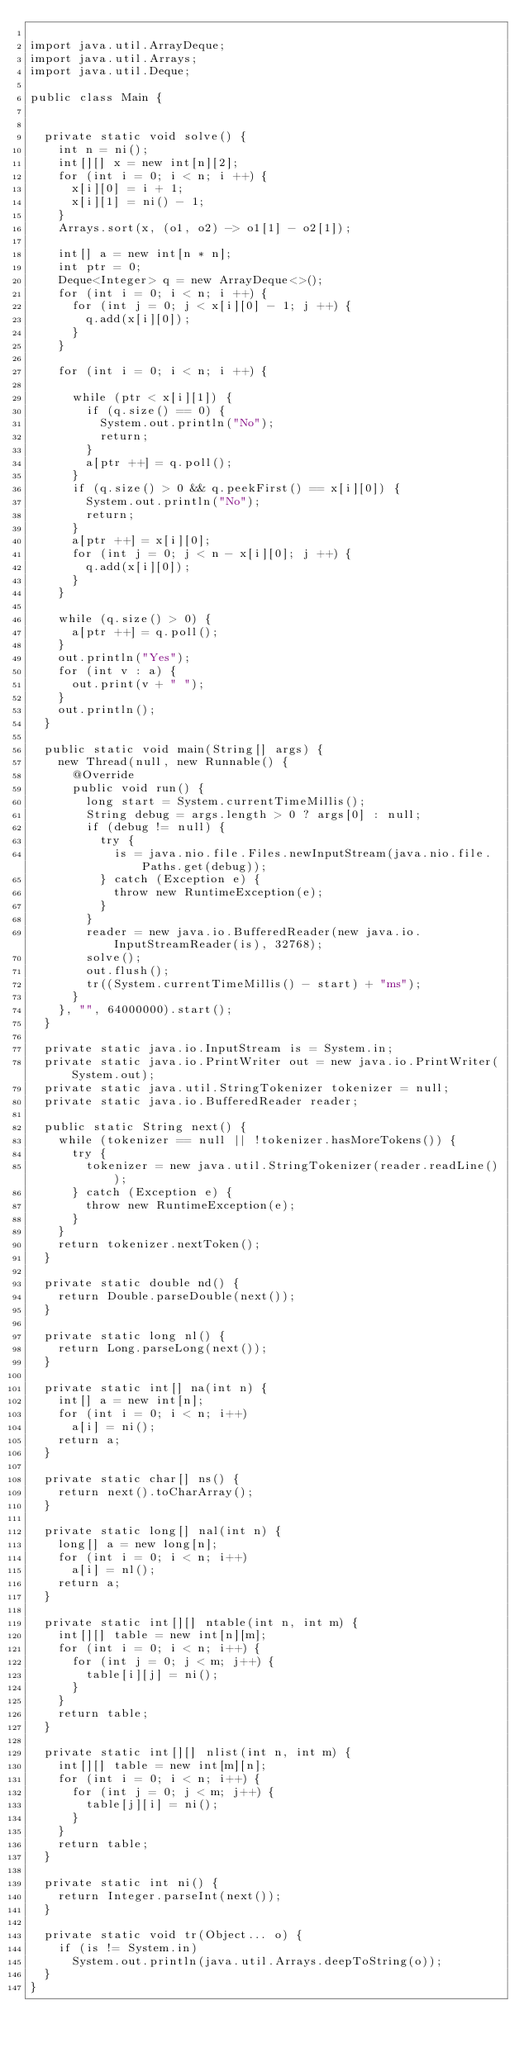<code> <loc_0><loc_0><loc_500><loc_500><_Java_>
import java.util.ArrayDeque;
import java.util.Arrays;
import java.util.Deque;

public class Main {


  private static void solve() {
    int n = ni();
    int[][] x = new int[n][2];
    for (int i = 0; i < n; i ++) {
      x[i][0] = i + 1;
      x[i][1] = ni() - 1;
    }
    Arrays.sort(x, (o1, o2) -> o1[1] - o2[1]);

    int[] a = new int[n * n];
    int ptr = 0;
    Deque<Integer> q = new ArrayDeque<>();
    for (int i = 0; i < n; i ++) {
      for (int j = 0; j < x[i][0] - 1; j ++) {
        q.add(x[i][0]);
      }
    }

    for (int i = 0; i < n; i ++) {

      while (ptr < x[i][1]) {
        if (q.size() == 0) {
          System.out.println("No");
          return;
        }
        a[ptr ++] = q.poll();
      }
      if (q.size() > 0 && q.peekFirst() == x[i][0]) {
        System.out.println("No");
        return;
      }
      a[ptr ++] = x[i][0];
      for (int j = 0; j < n - x[i][0]; j ++) {
        q.add(x[i][0]);
      }
    }

    while (q.size() > 0) {
      a[ptr ++] = q.poll();
    }
    out.println("Yes");
    for (int v : a) {
      out.print(v + " ");
    }
    out.println();
  }

  public static void main(String[] args) {
    new Thread(null, new Runnable() {
      @Override
      public void run() {
        long start = System.currentTimeMillis();
        String debug = args.length > 0 ? args[0] : null;
        if (debug != null) {
          try {
            is = java.nio.file.Files.newInputStream(java.nio.file.Paths.get(debug));
          } catch (Exception e) {
            throw new RuntimeException(e);
          }
        }
        reader = new java.io.BufferedReader(new java.io.InputStreamReader(is), 32768);
        solve();
        out.flush();
        tr((System.currentTimeMillis() - start) + "ms");
      }
    }, "", 64000000).start();
  }

  private static java.io.InputStream is = System.in;
  private static java.io.PrintWriter out = new java.io.PrintWriter(System.out);
  private static java.util.StringTokenizer tokenizer = null;
  private static java.io.BufferedReader reader;

  public static String next() {
    while (tokenizer == null || !tokenizer.hasMoreTokens()) {
      try {
        tokenizer = new java.util.StringTokenizer(reader.readLine());
      } catch (Exception e) {
        throw new RuntimeException(e);
      }
    }
    return tokenizer.nextToken();
  }

  private static double nd() {
    return Double.parseDouble(next());
  }

  private static long nl() {
    return Long.parseLong(next());
  }

  private static int[] na(int n) {
    int[] a = new int[n];
    for (int i = 0; i < n; i++)
      a[i] = ni();
    return a;
  }

  private static char[] ns() {
    return next().toCharArray();
  }

  private static long[] nal(int n) {
    long[] a = new long[n];
    for (int i = 0; i < n; i++)
      a[i] = nl();
    return a;
  }

  private static int[][] ntable(int n, int m) {
    int[][] table = new int[n][m];
    for (int i = 0; i < n; i++) {
      for (int j = 0; j < m; j++) {
        table[i][j] = ni();
      }
    }
    return table;
  }

  private static int[][] nlist(int n, int m) {
    int[][] table = new int[m][n];
    for (int i = 0; i < n; i++) {
      for (int j = 0; j < m; j++) {
        table[j][i] = ni();
      }
    }
    return table;
  }

  private static int ni() {
    return Integer.parseInt(next());
  }

  private static void tr(Object... o) {
    if (is != System.in)
      System.out.println(java.util.Arrays.deepToString(o));
  }
}
</code> 